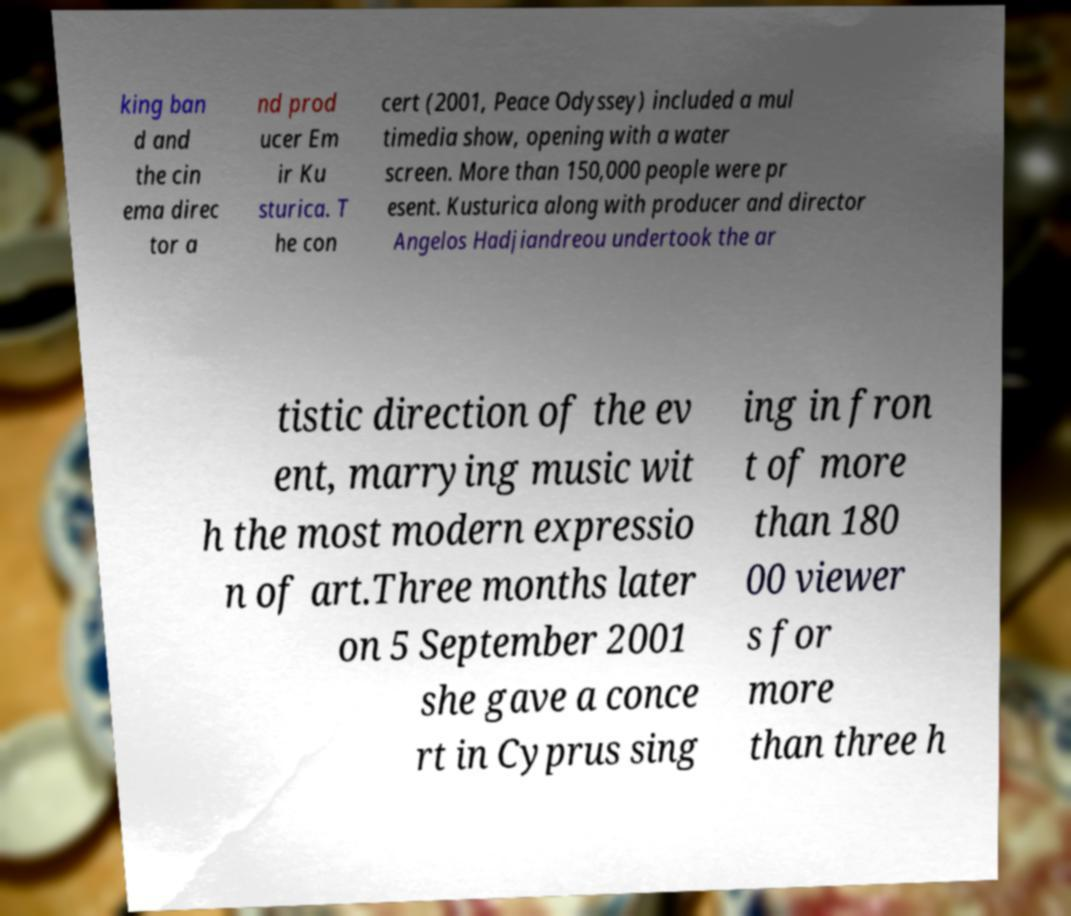Can you accurately transcribe the text from the provided image for me? king ban d and the cin ema direc tor a nd prod ucer Em ir Ku sturica. T he con cert (2001, Peace Odyssey) included a mul timedia show, opening with a water screen. More than 150,000 people were pr esent. Kusturica along with producer and director Angelos Hadjiandreou undertook the ar tistic direction of the ev ent, marrying music wit h the most modern expressio n of art.Three months later on 5 September 2001 she gave a conce rt in Cyprus sing ing in fron t of more than 180 00 viewer s for more than three h 